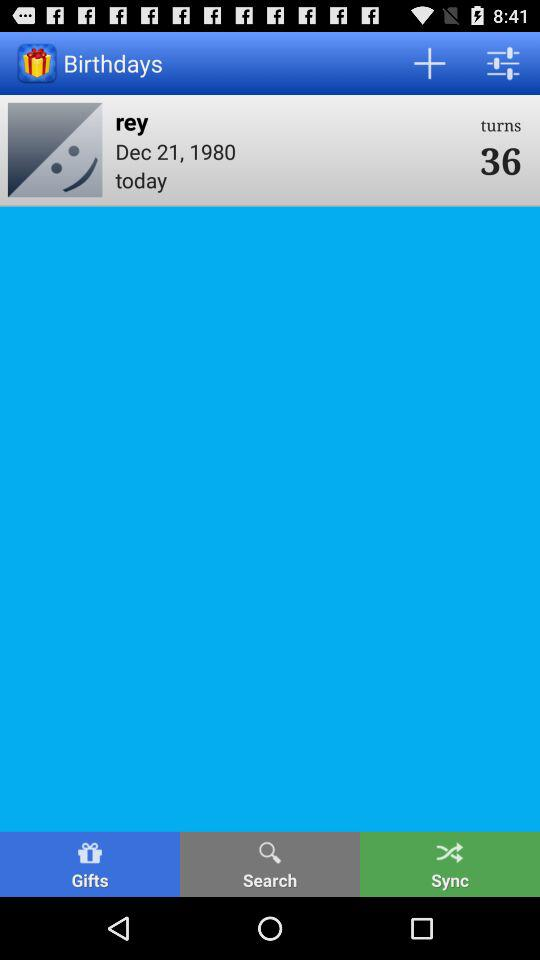How many more years will Rey have to wait until she turns 40?
Answer the question using a single word or phrase. 4 